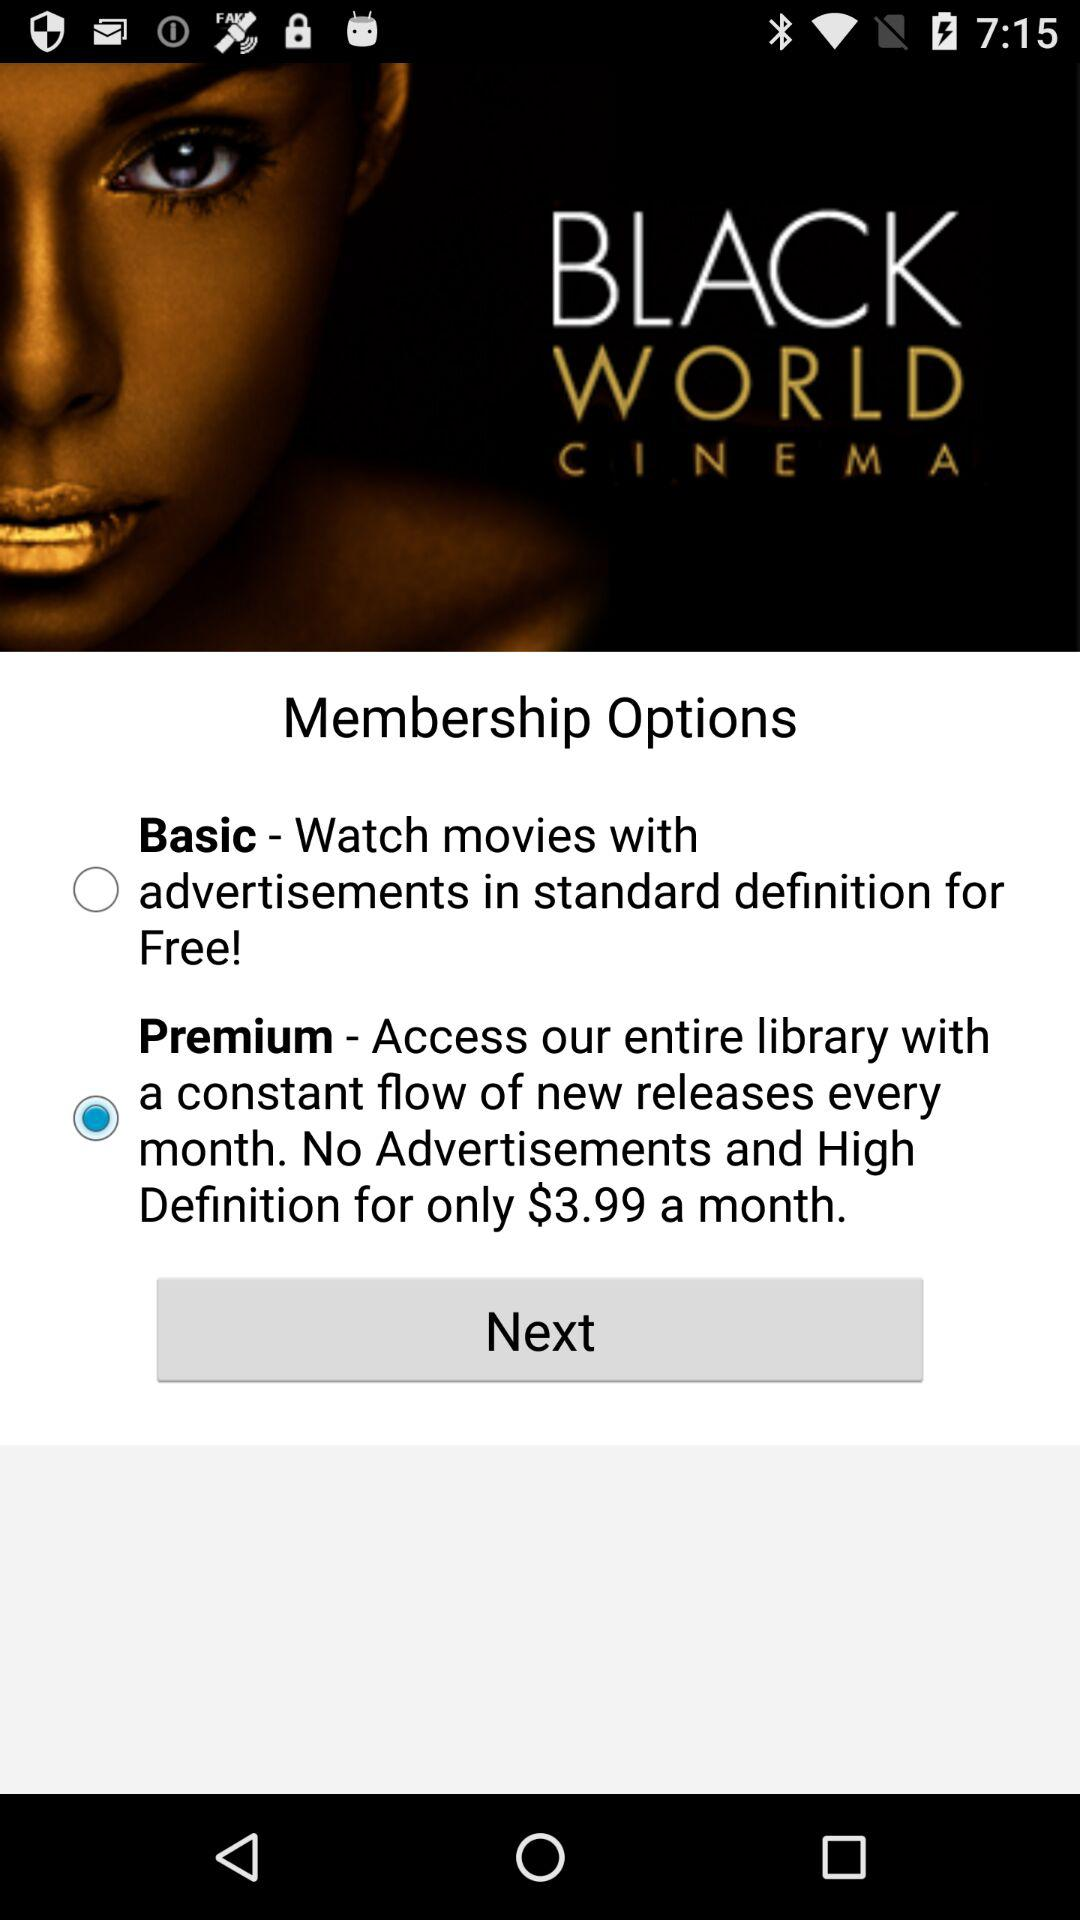Which membership option is selected? The selected membership option is "Premium". 